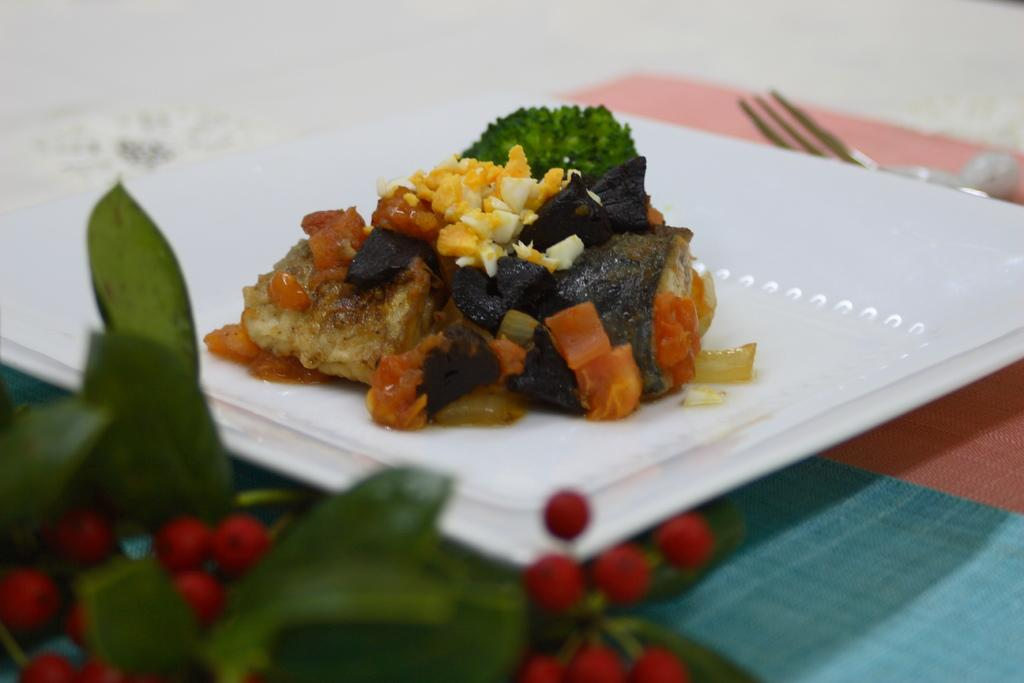What color is the plate that is visible in the image? There is a white color plate in the image. What is on the plate in the image? There is a food item on the plate. What utensil can be seen on the table in the image? There is a fork on the table. What is located in the bottom left of the image? There are fruits and leaves in the bottom left of the image. How does the bomb explode in the image? There is no bomb present in the image; it is a plate with a food item, a fork, and fruits and leaves in the bottom left. 